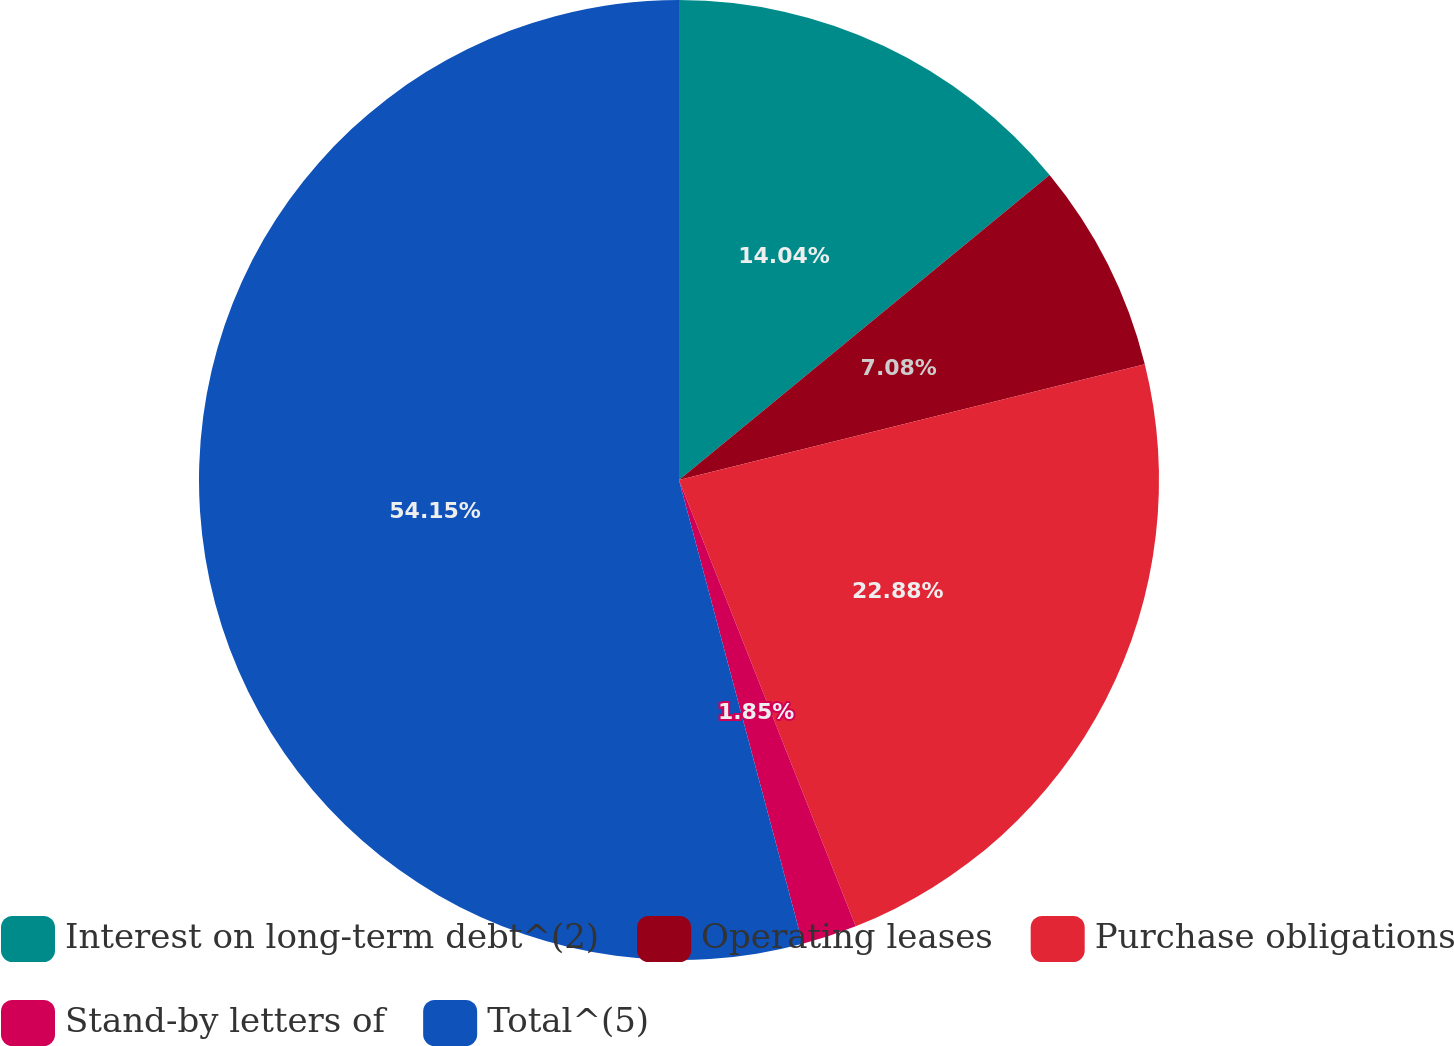<chart> <loc_0><loc_0><loc_500><loc_500><pie_chart><fcel>Interest on long-term debt^(2)<fcel>Operating leases<fcel>Purchase obligations<fcel>Stand-by letters of<fcel>Total^(5)<nl><fcel>14.04%<fcel>7.08%<fcel>22.88%<fcel>1.85%<fcel>54.15%<nl></chart> 